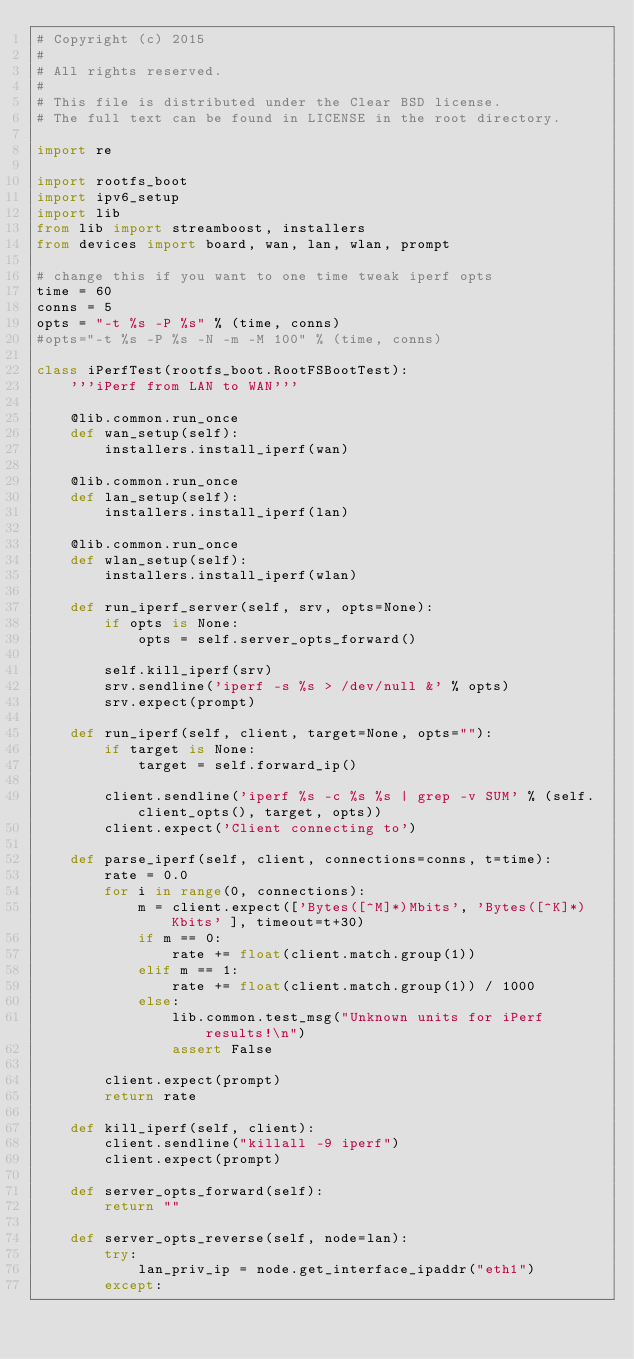Convert code to text. <code><loc_0><loc_0><loc_500><loc_500><_Python_># Copyright (c) 2015
#
# All rights reserved.
#
# This file is distributed under the Clear BSD license.
# The full text can be found in LICENSE in the root directory.

import re

import rootfs_boot
import ipv6_setup
import lib
from lib import streamboost, installers
from devices import board, wan, lan, wlan, prompt

# change this if you want to one time tweak iperf opts
time = 60
conns = 5
opts = "-t %s -P %s" % (time, conns)
#opts="-t %s -P %s -N -m -M 100" % (time, conns)

class iPerfTest(rootfs_boot.RootFSBootTest):
    '''iPerf from LAN to WAN'''

    @lib.common.run_once
    def wan_setup(self):
        installers.install_iperf(wan)

    @lib.common.run_once
    def lan_setup(self):
        installers.install_iperf(lan)

    @lib.common.run_once
    def wlan_setup(self):
        installers.install_iperf(wlan)

    def run_iperf_server(self, srv, opts=None):
        if opts is None:
            opts = self.server_opts_forward()

        self.kill_iperf(srv)
        srv.sendline('iperf -s %s > /dev/null &' % opts)
        srv.expect(prompt)

    def run_iperf(self, client, target=None, opts=""):
        if target is None:
            target = self.forward_ip()

        client.sendline('iperf %s -c %s %s | grep -v SUM' % (self.client_opts(), target, opts))
        client.expect('Client connecting to')

    def parse_iperf(self, client, connections=conns, t=time):
        rate = 0.0
        for i in range(0, connections):
            m = client.expect(['Bytes([^M]*)Mbits', 'Bytes([^K]*)Kbits' ], timeout=t+30)
            if m == 0:
                rate += float(client.match.group(1))
            elif m == 1:
                rate += float(client.match.group(1)) / 1000
            else:
                lib.common.test_msg("Unknown units for iPerf results!\n")
                assert False

        client.expect(prompt)
        return rate

    def kill_iperf(self, client):
        client.sendline("killall -9 iperf")
        client.expect(prompt)

    def server_opts_forward(self):
        return ""

    def server_opts_reverse(self, node=lan):
        try:
            lan_priv_ip = node.get_interface_ipaddr("eth1")
        except:</code> 